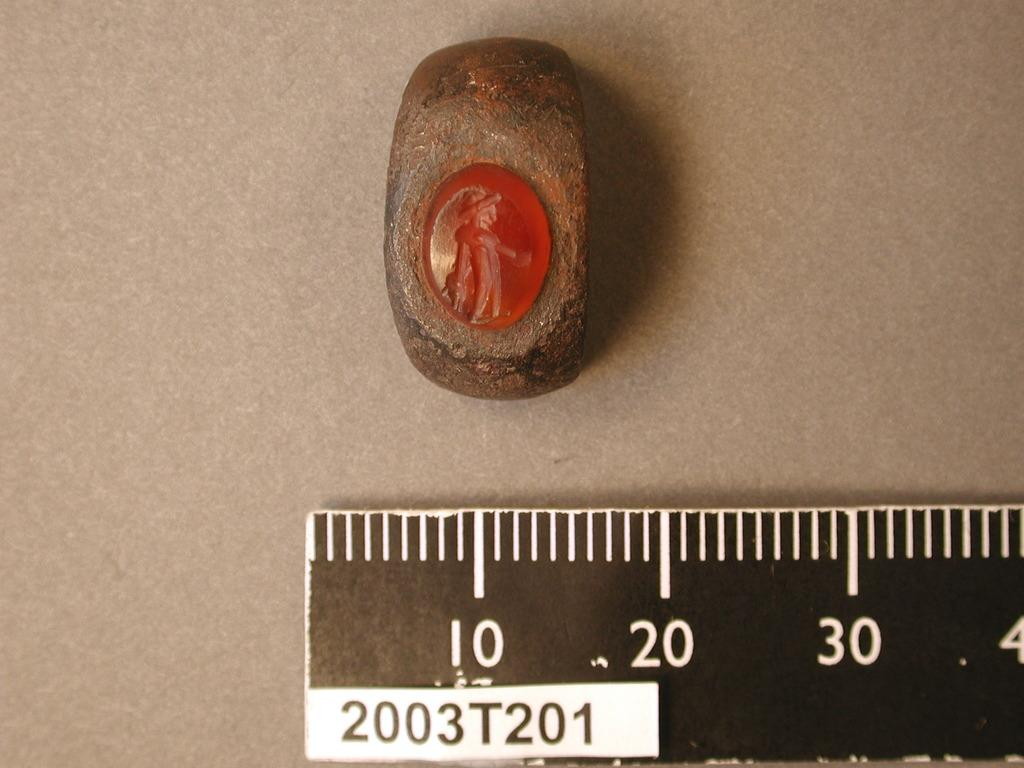What is the main object in the image? There is a scale in the image. What is happening to the objects on the scale? The objects are on the surface of the scale. What type of volcano can be seen erupting in the background of the image? There is no volcano present in the image; it only features a scale with objects on its surface. 